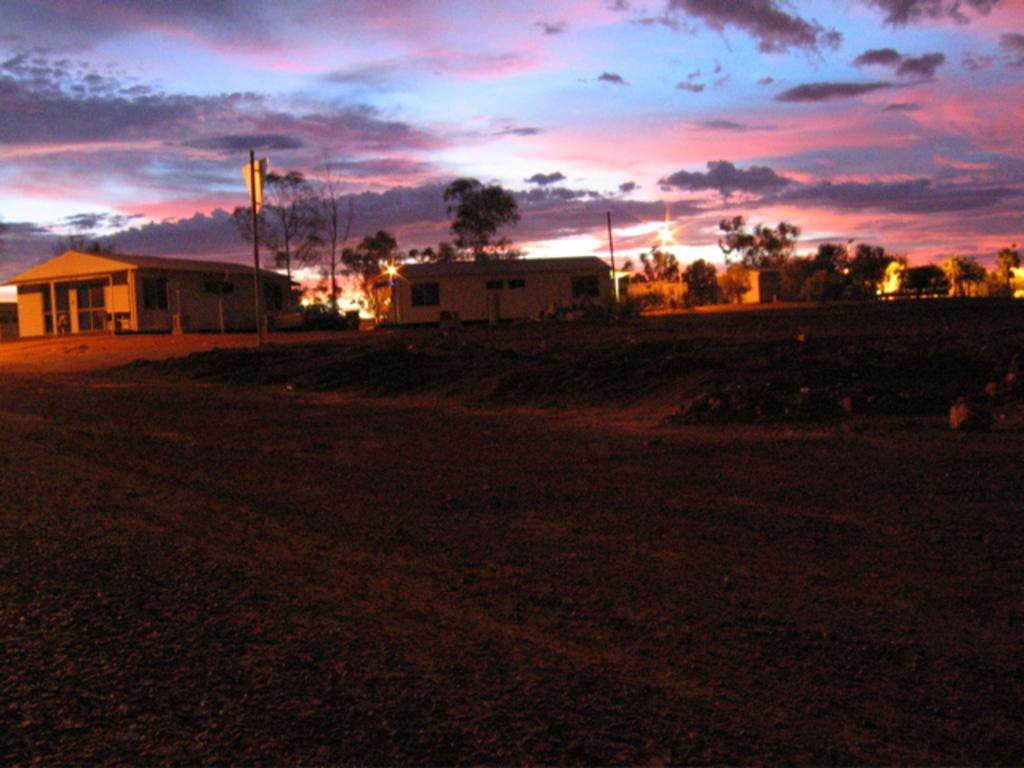What type of surface is visible in the image? The image contains a muddy surface. What can be seen in the distance in the image? There is a pole visible in the distance. What is visible in the background of the image? There are houses, trees, and the sky visible in the background of the image. What is the condition of the sky in the image? Clouds are present in the sky in the image. What type of spoon is being used to create the shade in the image? There is no spoon or shade present in the image. 